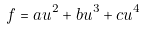<formula> <loc_0><loc_0><loc_500><loc_500>f = a u ^ { 2 } + b u ^ { 3 } + c u ^ { 4 }</formula> 